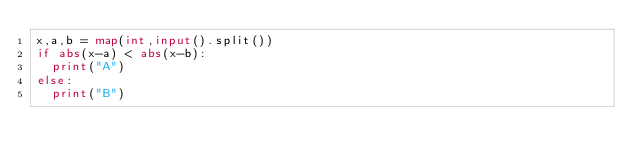Convert code to text. <code><loc_0><loc_0><loc_500><loc_500><_Python_>x,a,b = map(int,input().split())
if abs(x-a) < abs(x-b):
  print("A")
else:
  print("B")</code> 